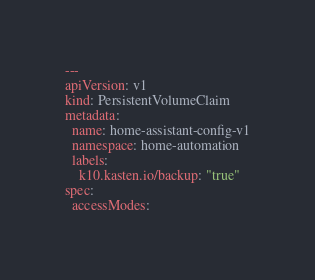<code> <loc_0><loc_0><loc_500><loc_500><_YAML_>---
apiVersion: v1
kind: PersistentVolumeClaim
metadata:
  name: home-assistant-config-v1
  namespace: home-automation
  labels:
    k10.kasten.io/backup: "true"
spec:
  accessModes:</code> 